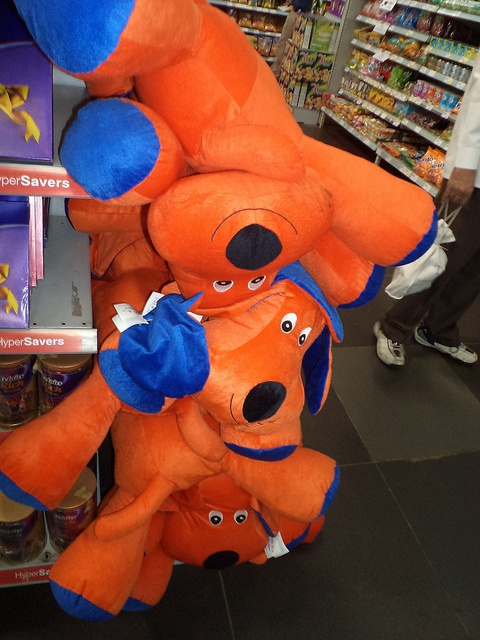Describe the objects in this image and their specific colors. I can see dog in black, brown, and red tones, dog in black, red, and brown tones, people in black, darkgray, lightgray, and gray tones, book in black, purple, violet, and gold tones, and handbag in black, darkgray, gray, and lightgray tones in this image. 